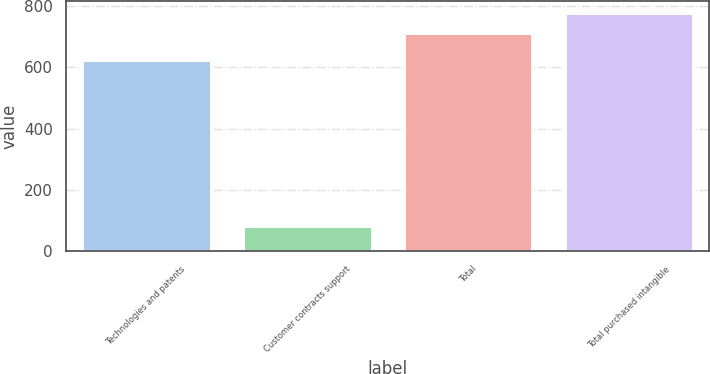Convert chart. <chart><loc_0><loc_0><loc_500><loc_500><bar_chart><fcel>Technologies and patents<fcel>Customer contracts support<fcel>Total<fcel>Total purchased intangible<nl><fcel>624.9<fcel>83.6<fcel>710.5<fcel>778.09<nl></chart> 